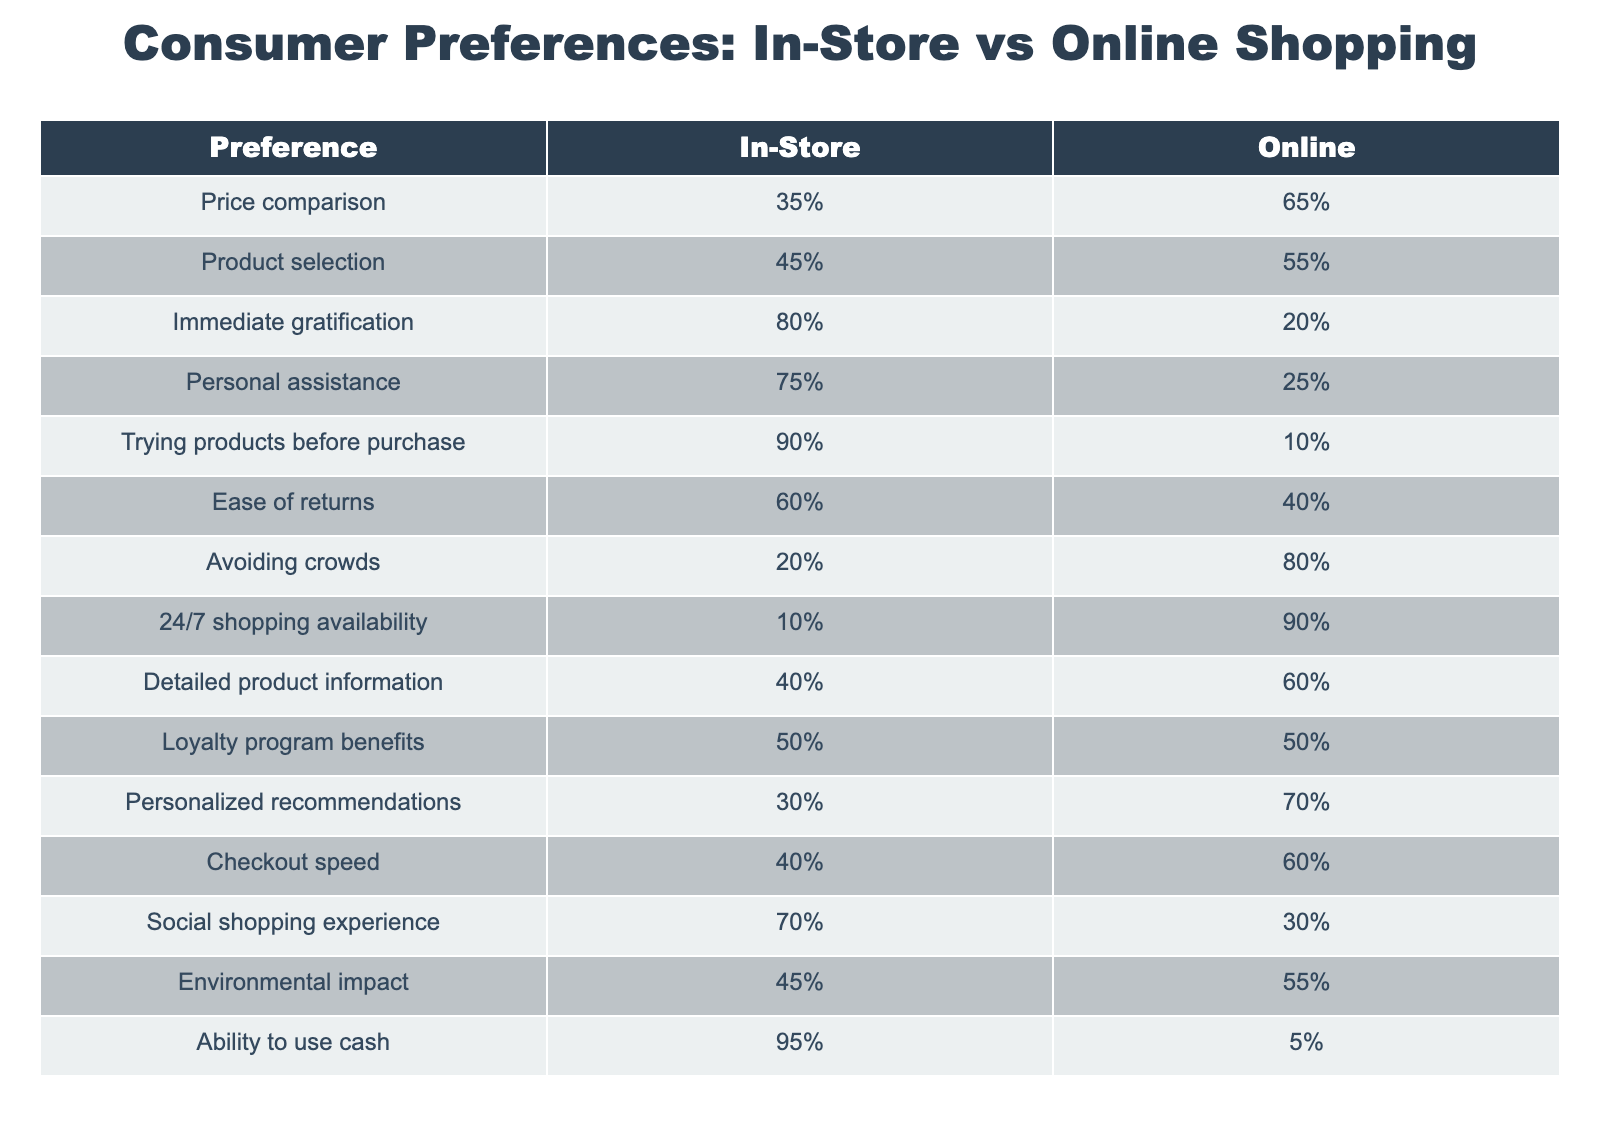What is the percentage of consumers who prefer in-store shopping for immediate gratification? The table shows that 80% of consumers prefer in-store shopping for immediate gratification.
Answer: 80% Which preference has the highest percentage for online shopping? When reviewing the table, we see that '24/7 shopping availability' has the highest percentage for online shopping at 90%.
Answer: 90% Is the preference for trying products before purchase higher for in-store or online shopping? The table indicates that 90% of consumers prefer trying products before purchase in-store compared to only 10% online.
Answer: In-store What is the difference in percentage between in-store and online preferences for personal assistance? The in-store preference for personal assistance is 75% and online is 25%. The difference is 75% - 25% = 50%.
Answer: 50% What percentage of consumers prefer online shopping for detailed product information? According to the data, 60% of consumers prefer online shopping for detailed product information.
Answer: 60% For the preference 'Ability to use cash', is it true that a majority of consumers prefer in-store shopping? Yes, the table shows that 95% of consumers prefer in-store shopping when it comes to the ability to use cash.
Answer: Yes What is the average percentage of preference for online shopping across all categories? To calculate the average percentage for online shopping, we sum up the online percentages: 65 + 55 + 20 + 25 + 10 + 40 + 80 + 90 + 60 + 50 + 70 + 60 + 30 + 55 + 5 =  47. To find the average, we divide that sum by the number of categories (15), which gives us about 47 / 15 = 49.33%.
Answer: 49.33% What percentage of consumers avoid crowds when shopping online? The table indicates that 80% of consumers prefer to avoid crowds when shopping online.
Answer: 80% How many preferences have a higher percentage for in-store shopping compared to online shopping? By reviewing the table, we see that the preferences 'Immediate gratification', 'Personal assistance', 'Trying products before purchase', and 'Ability to use cash' all have higher percentages for in-store shopping. In total, there are 4 preferences with this characteristic.
Answer: 4 